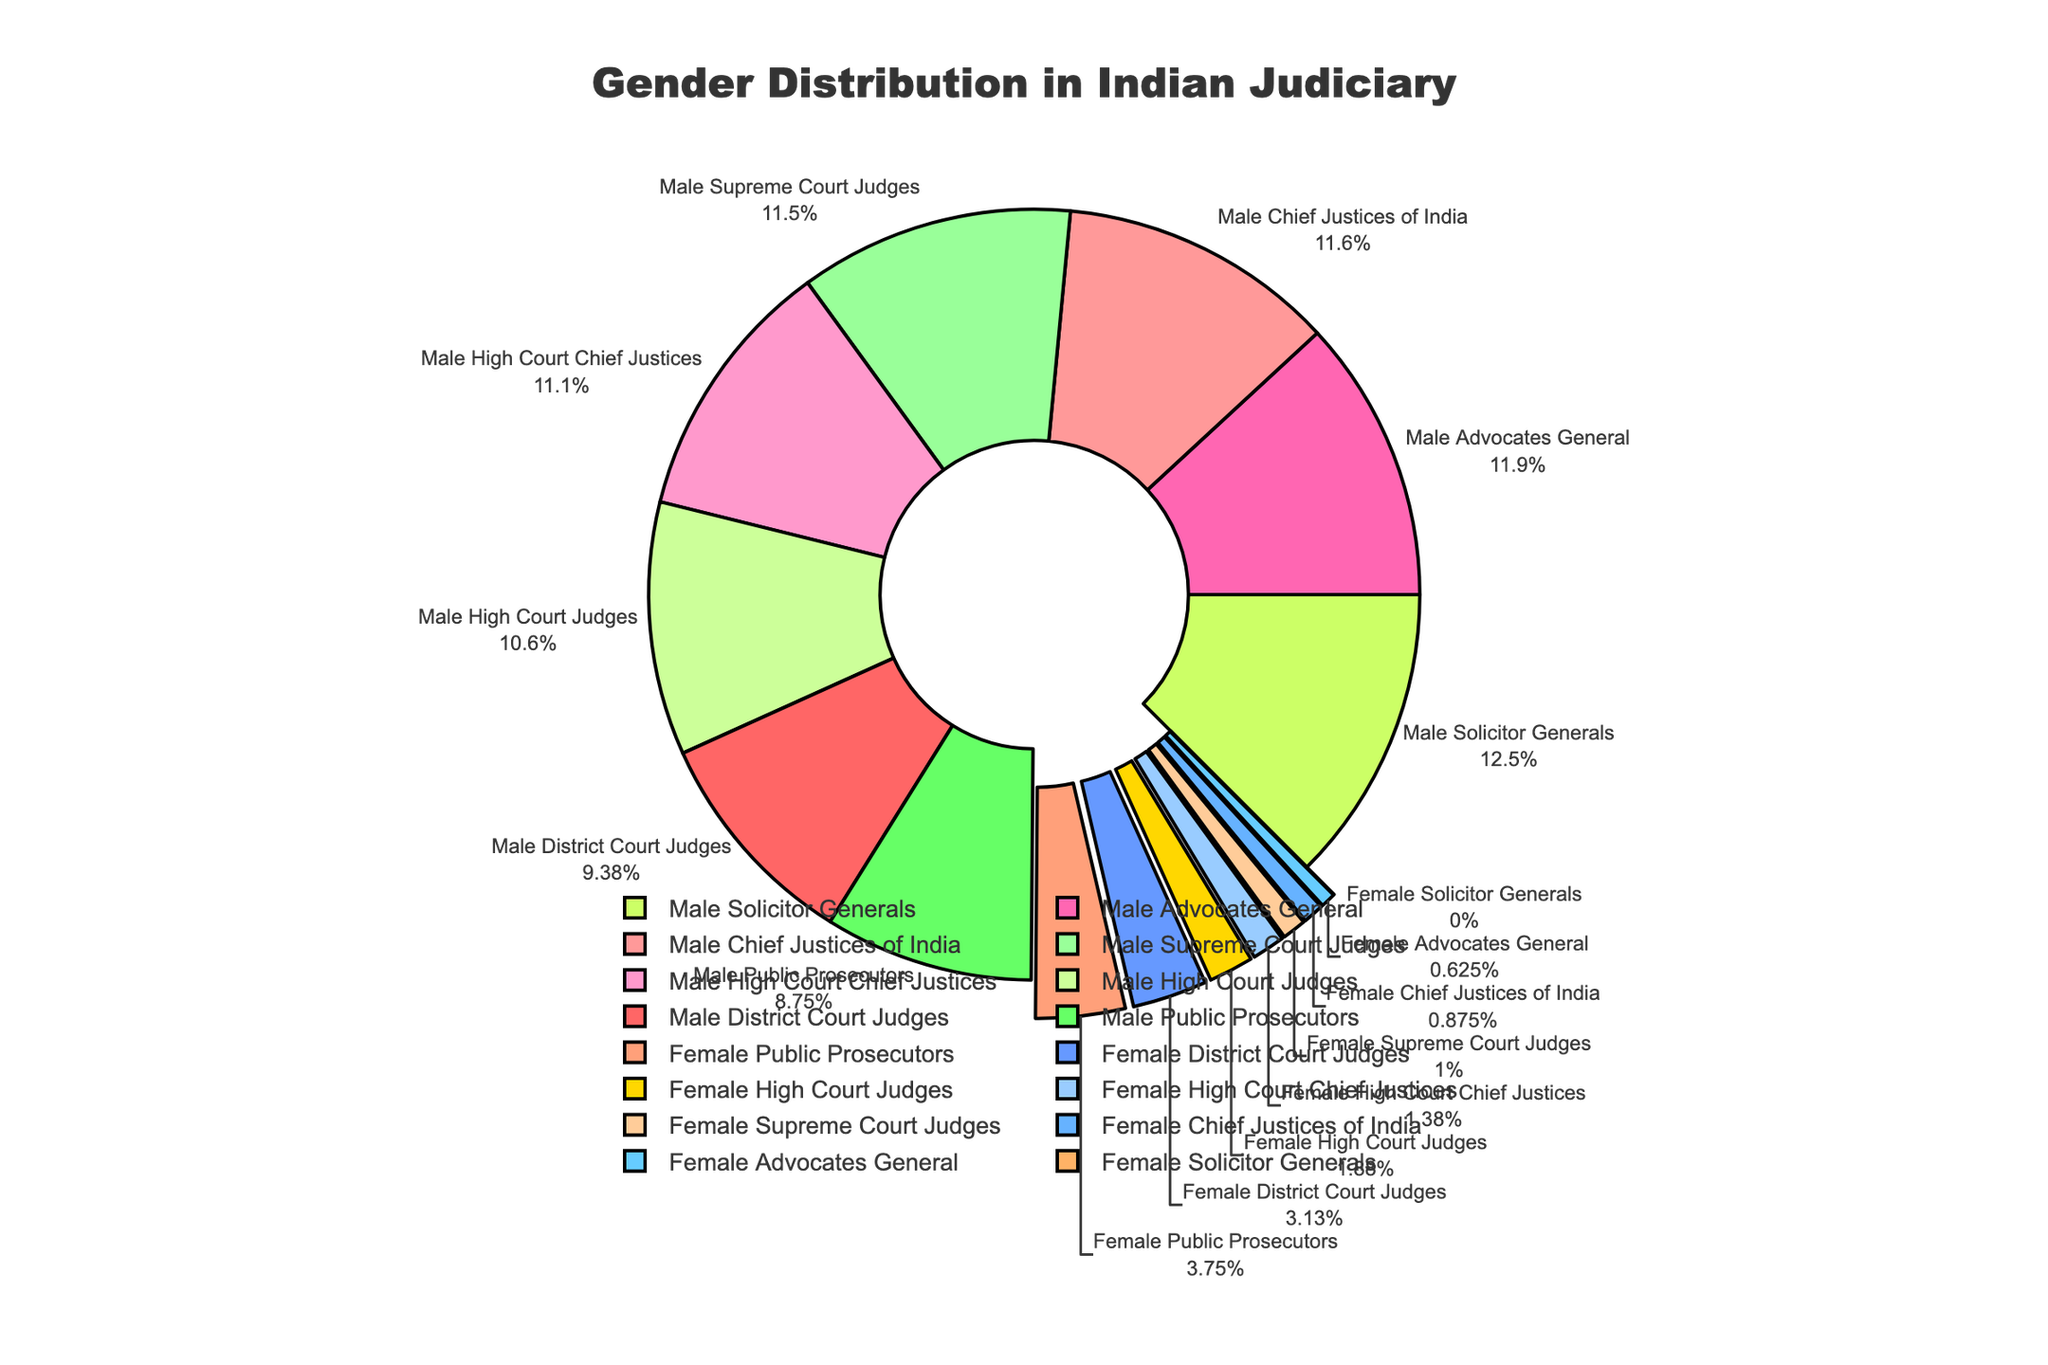What percentage of Chief Justices of India are female? Look at the segment labeled "Female Chief Justices of India" in the pie chart. It shows 7%.
Answer: 7% Which position has the highest percentage of males? Observe the labels and corresponding percentages in the pie chart. The "Male Solicitor Generals" segment shows 100%.
Answer: Solicitor Generals Compare the percentage of female District Court Judges with female High Court Judges. Which is higher? Examine the segments labeled "Female District Court Judges" (25%) and "Female High Court Judges" (15%) in the pie chart.
Answer: Female District Court Judges What is the combined percentage of male and female Advocates General? Add the two segments labeled "Male Advocates General" (95%) and "Female Advocates General" (5%). 95% + 5% = 100%.
Answer: 100% How much higher is the percentage of male Public Prosecutors compared to female Public Prosecutors? Subtract the percentage of "Female Public Prosecutors" (30%) from "Male Public Prosecutors" (70%). 70% - 30% = 40%.
Answer: 40% What is the average percentage of female judges across all court levels listed (Chief Justices, Supreme Court Judges, High Court Judges, District Court Judges)? Add the percentages of female judges at different court levels: 7% (Chief Justices of India) + 8% (Supreme Court Judges) + 11% (High Court Chief Justices) + 15% (High Court Judges) + 25% (District Court Judges) = 66%. Divide by the number of levels (5): 66% / 5 = 13.2%.
Answer: 13.2% Is the percentage of female High Court Chief Justices higher than female High Court Judges? Compare the segments labeled "Female High Court Chief Justices" (11%) and "Female High Court Judges" (15%). 15% is higher than 11%.
Answer: No What percentage of the positions listed are represented by females? Add the percentages of female representatives across different positions: 7% (Chief Justices of India) + 8% (Supreme Court Judges) + 11% (High Court Chief Justices) + 15% (High Court Judges) + 25% (District Court Judges) + 30% (Public Prosecutors) + 5% (Advocates General) + 0% (Solicitor Generals) = 101%.
Answer: 101% Which gender has greater representation as Supreme Court Judges? Examine the segments labeled "Male Supreme Court Judges" (92%) and "Female Supreme Court Judges" (8%). Male representation is higher.
Answer: Male What is the visual significance of the segments being pulled outward in the pie chart? The segments pulled outward indicate female representation in each judicial position.
Answer: Highlighting female representation 